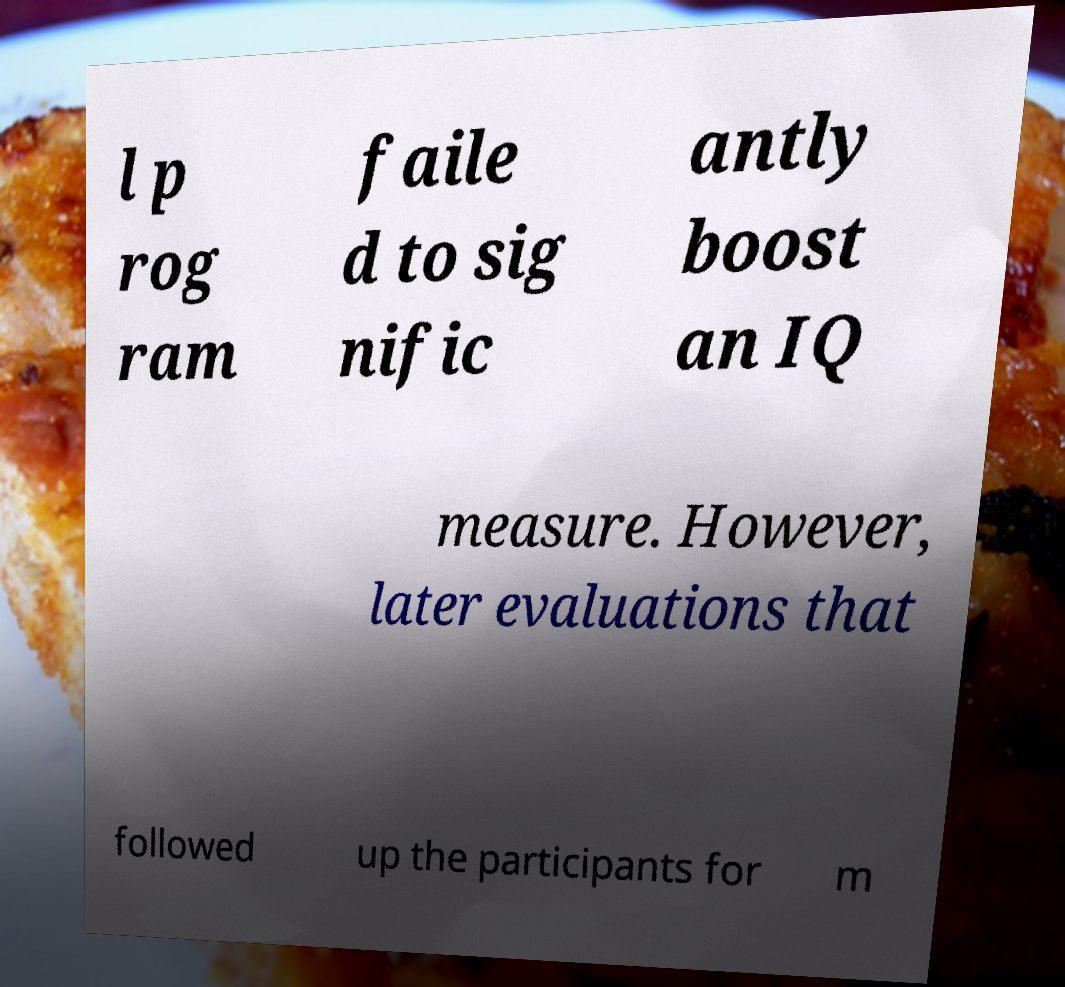Can you accurately transcribe the text from the provided image for me? l p rog ram faile d to sig nific antly boost an IQ measure. However, later evaluations that followed up the participants for m 